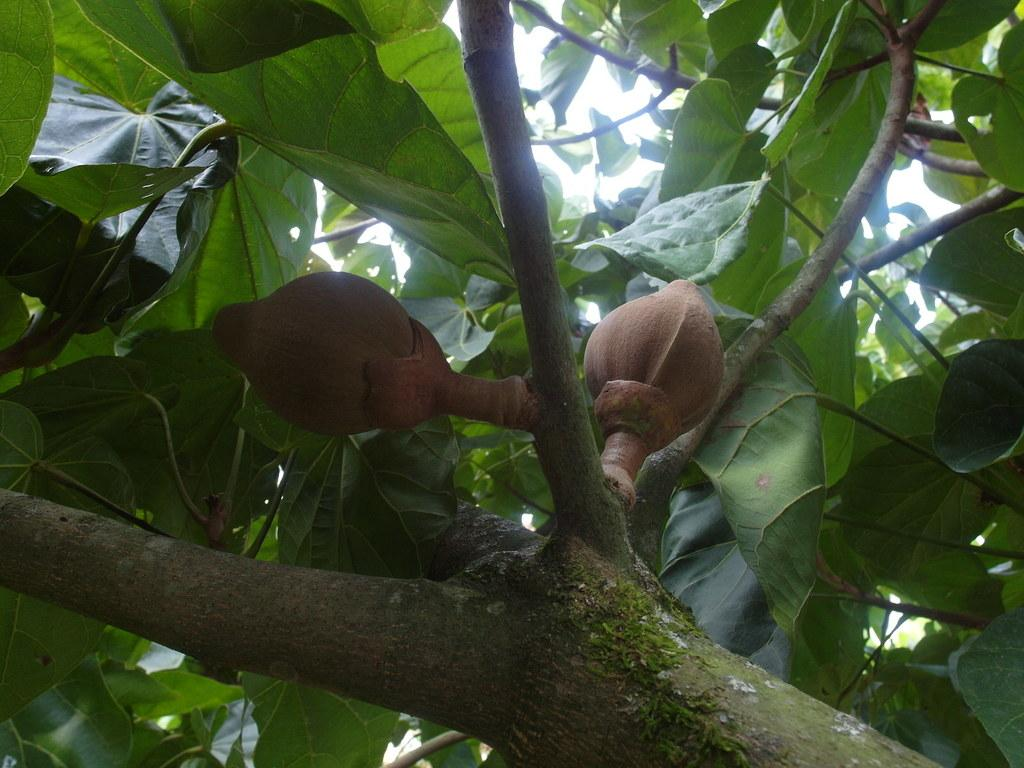What is at the bottom of the image? There are branches with two fruits at the bottom of the image. What color are the leaves on the branches? The leaves on the branches have a green color. What can be seen in the background of the image besides the sky? There are green color leaves in the background of the image. What is visible in the sky in the image? The sky is visible in the background of the image. Where is the control panel for the station located in the image? There is no control panel or station present in the image; it features branches with fruits and leaves. 